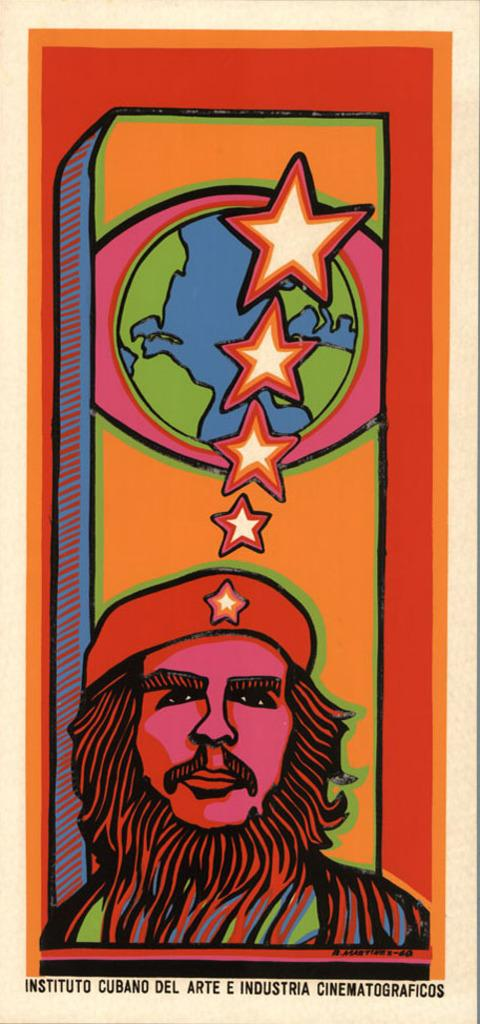What type of visual is the image? The image is a poster. Who or what is featured on the poster? There is a person depicted on the poster. What additional object is present on the poster? There is a globe on the poster. What type of symbols can be seen on the poster? Star symbols are present on the poster. What information is provided at the bottom of the poster? There is text at the bottom of the poster. What color is the butter on the sweater in the image? There is no butter or sweater present in the image; it features a person, a globe, and star symbols on a poster. How many wheels can be seen on the poster? There are no wheels depicted on the poster. 